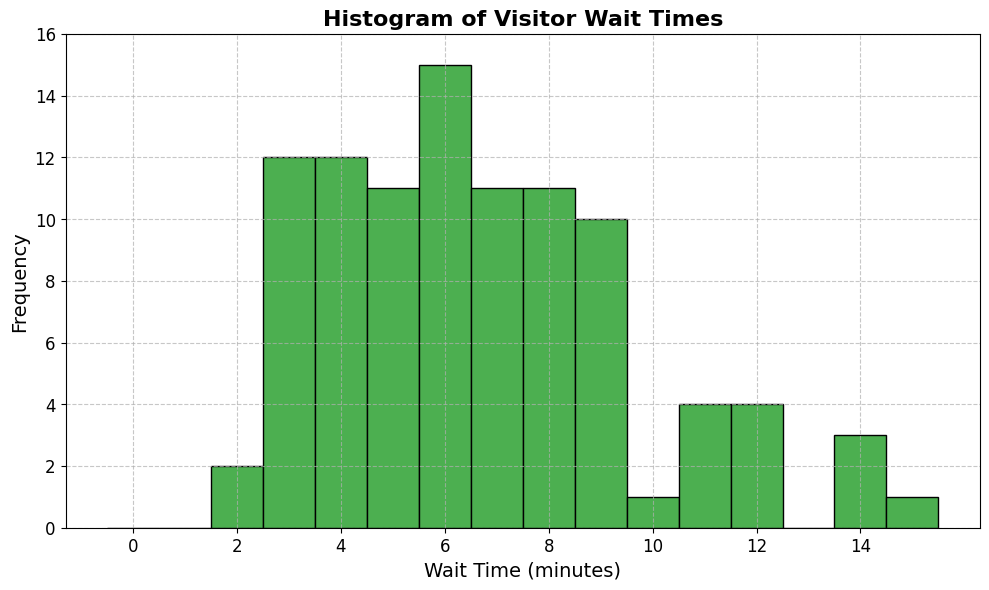What is the most frequent wait time range? The most frequent wait time range can be identified by observing the tallest bar in the histogram. The tallest bar corresponds to the wait times between 4-5 minutes.
Answer: 4-5 minutes How many times did visitors wait for 7 minutes? To find this, look for the bar that corresponds to the 7-minute mark on the x-axis. The height of the bar represents the frequency. In this case, the bar at 7 minutes reaches up to 6 ticks on the y-axis.
Answer: 6 times What is the total frequency of wait times less than or equal to 5 minutes? Identify the bars that correspond to wait times 2, 3, 4, and 5 minutes and sum their heights. The counts are: 2 (frequency: 4), 3 (frequency: 6), 4 (frequency: 11), 5 (frequency: 9). Summing them up, 4 + 6 + 11 + 9 = 30.
Answer: 30 Which wait time range has a higher frequency: 10-11 minutes or 12-13 minutes? Locate the bars for the 10-11 minutes range and the 12-13 minutes range. The bar for 10-11 minutes has a height of around 3, while the bar for 12-13 minutes also has a height of 3. Comparatively, both ranges have the same height.
Answer: Same frequency What is the range of wait times displayed in the histogram? Identify the smallest and largest values on the x-axis. The smallest wait time is 2 minutes, and the largest wait time is 15 minutes. The range is from 2 to 15 minutes.
Answer: 2 to 15 minutes Is the distribution of wait times skewed, and if so, in which direction? Observe the shape of the histogram. The bars are more frequent towards the shorter wait times (left side) and less frequent towards the longer wait times (right side), indicating a right (positive) skew.
Answer: Right-skewed How many times did visitors wait more than 10 minutes? Identify and sum the frequencies of the bars corresponding to wait times 11, 12, 14, and 15 minutes. The counts are: 11 (frequency: 4), 12 (frequency: 3), 14 (frequency: 2), and 15 (frequency: 1). Summing them up, 4 + 3 + 2 + 1 = 10.
Answer: 10 times 